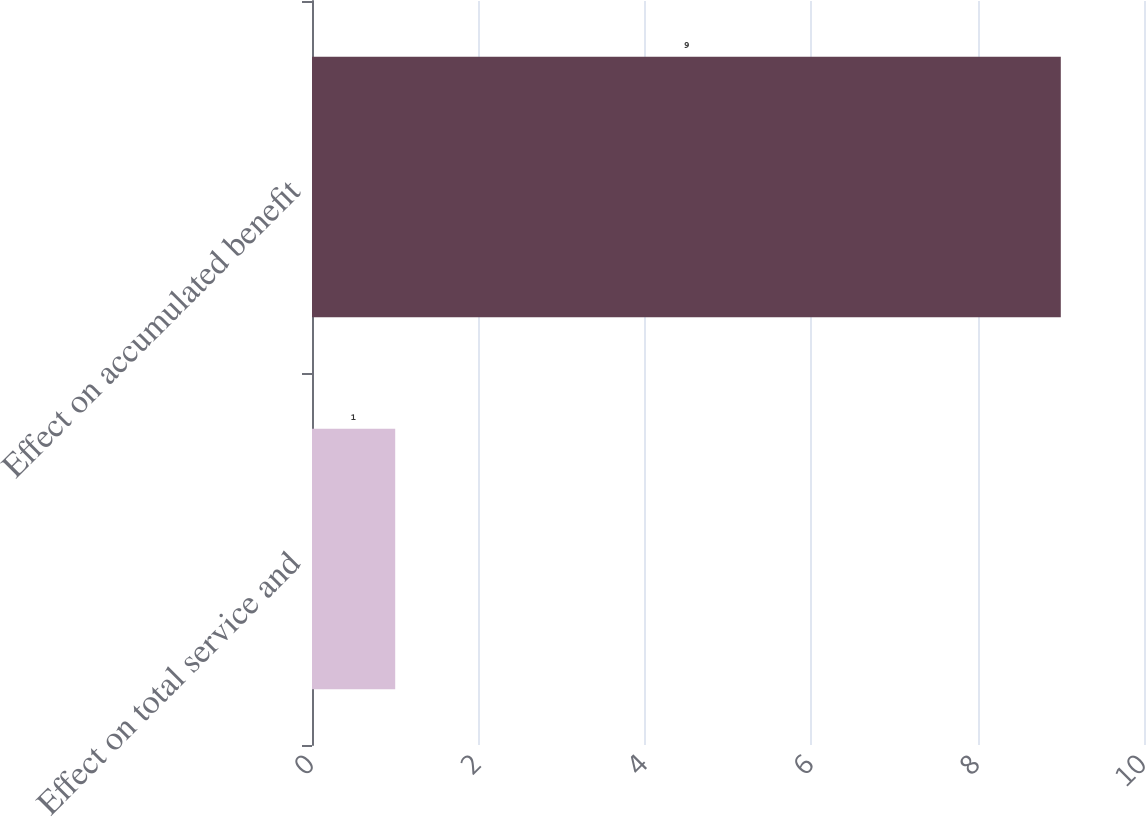<chart> <loc_0><loc_0><loc_500><loc_500><bar_chart><fcel>Effect on total service and<fcel>Effect on accumulated benefit<nl><fcel>1<fcel>9<nl></chart> 